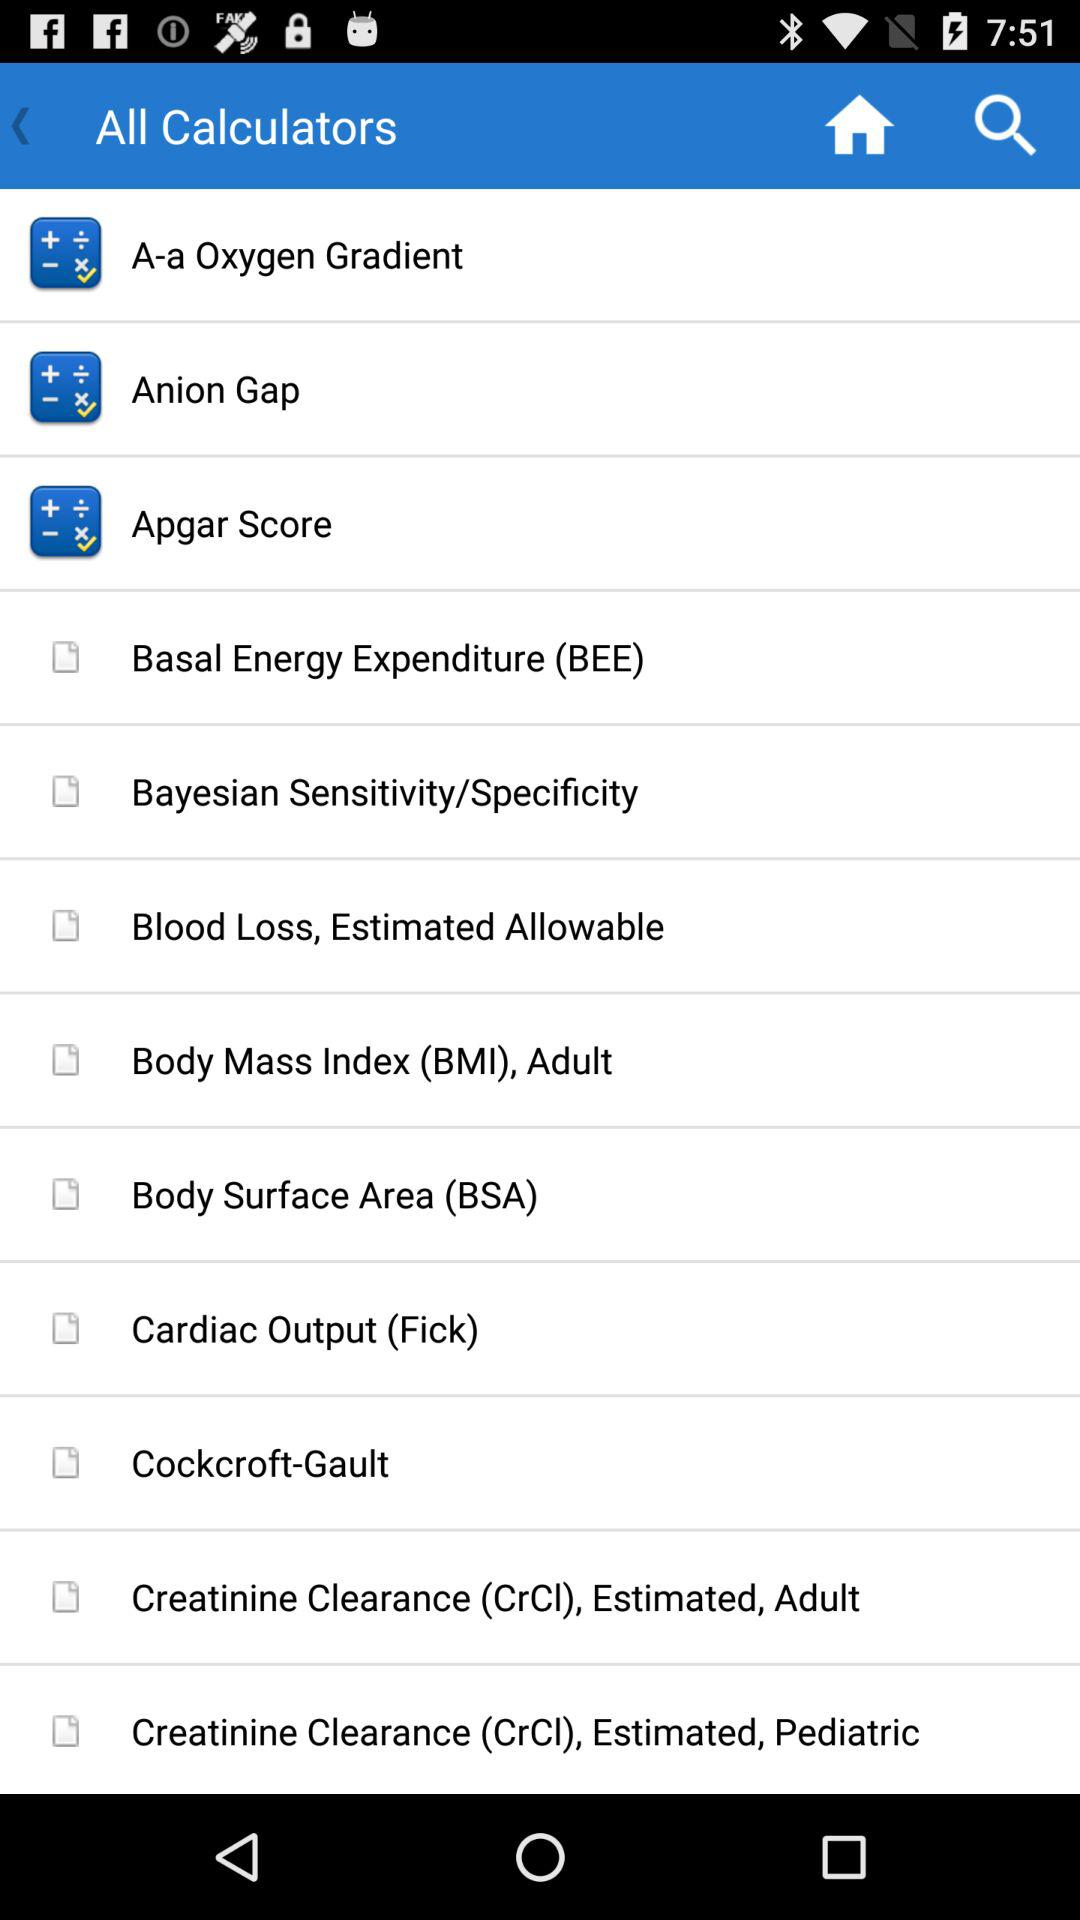What is the full form of BSA? The full form is "Body Surface Area". 